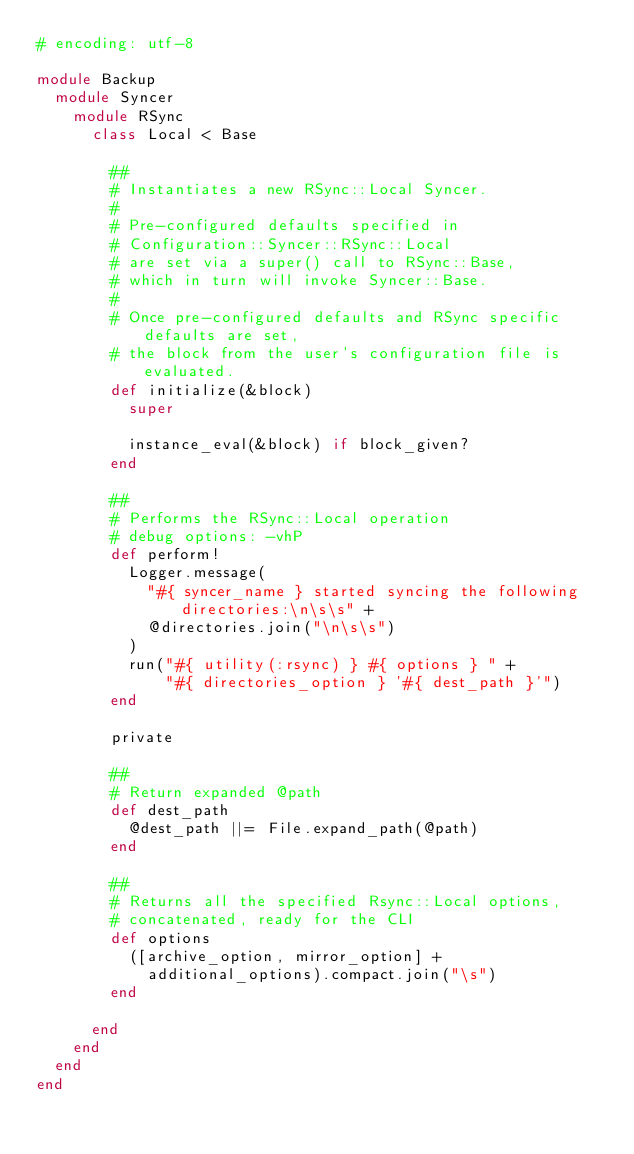<code> <loc_0><loc_0><loc_500><loc_500><_Ruby_># encoding: utf-8

module Backup
  module Syncer
    module RSync
      class Local < Base

        ##
        # Instantiates a new RSync::Local Syncer.
        #
        # Pre-configured defaults specified in
        # Configuration::Syncer::RSync::Local
        # are set via a super() call to RSync::Base,
        # which in turn will invoke Syncer::Base.
        #
        # Once pre-configured defaults and RSync specific defaults are set,
        # the block from the user's configuration file is evaluated.
        def initialize(&block)
          super

          instance_eval(&block) if block_given?
        end

        ##
        # Performs the RSync::Local operation
        # debug options: -vhP
        def perform!
          Logger.message(
            "#{ syncer_name } started syncing the following directories:\n\s\s" +
            @directories.join("\n\s\s")
          )
          run("#{ utility(:rsync) } #{ options } " +
              "#{ directories_option } '#{ dest_path }'")
        end

        private

        ##
        # Return expanded @path
        def dest_path
          @dest_path ||= File.expand_path(@path)
        end

        ##
        # Returns all the specified Rsync::Local options,
        # concatenated, ready for the CLI
        def options
          ([archive_option, mirror_option] +
            additional_options).compact.join("\s")
        end

      end
    end
  end
end
</code> 